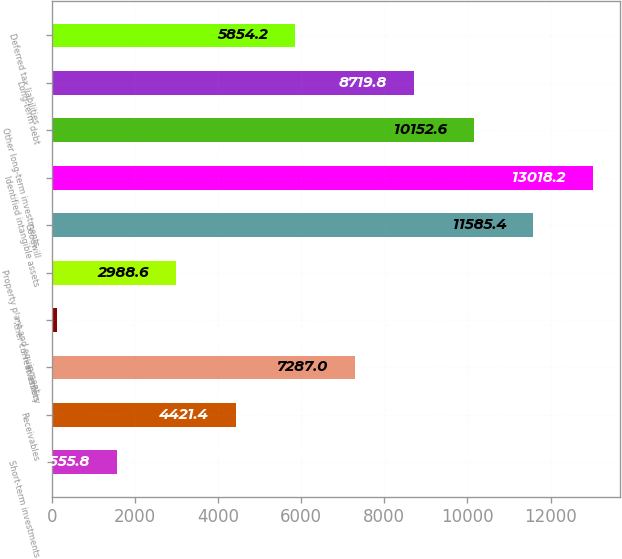Convert chart. <chart><loc_0><loc_0><loc_500><loc_500><bar_chart><fcel>Short-term investments<fcel>Receivables<fcel>Inventory<fcel>Other current assets<fcel>Property plant and equipment<fcel>Goodwill<fcel>Identified intangible assets<fcel>Other long-term investments<fcel>Long-term debt<fcel>Deferred tax liabilities<nl><fcel>1555.8<fcel>4421.4<fcel>7287<fcel>123<fcel>2988.6<fcel>11585.4<fcel>13018.2<fcel>10152.6<fcel>8719.8<fcel>5854.2<nl></chart> 